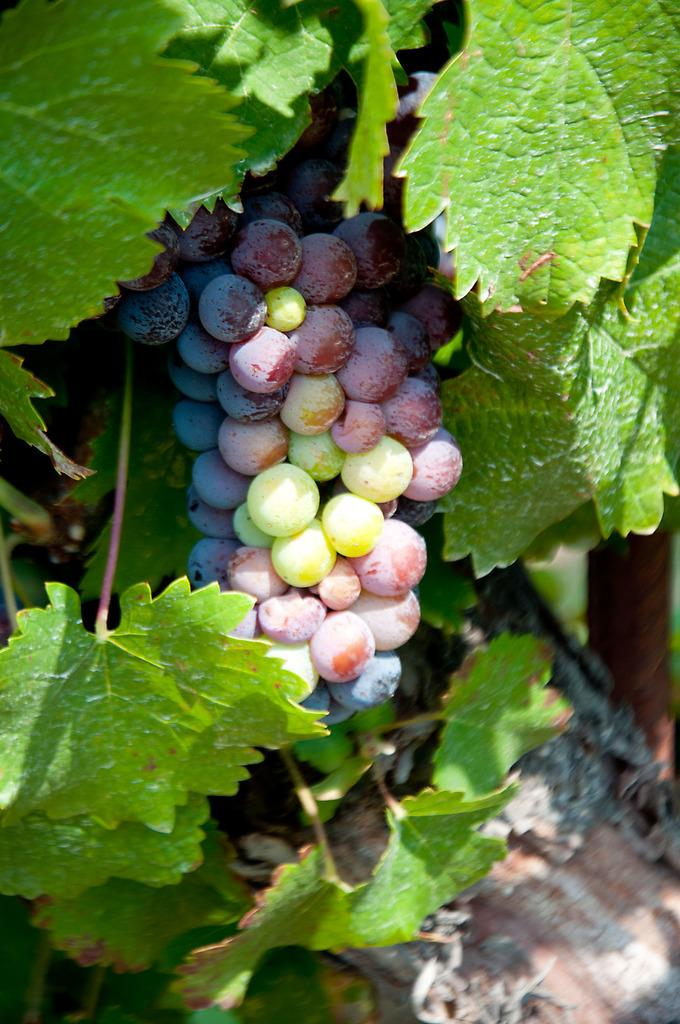What type of fruit is present in the image? There is a bunch of grapes in the image. What else can be seen in the image besides the grapes? Leaves are visible in the image. What advice does the mother give to the beetle in the image? There is no mother or beetle present in the image, so this question cannot be answered. 